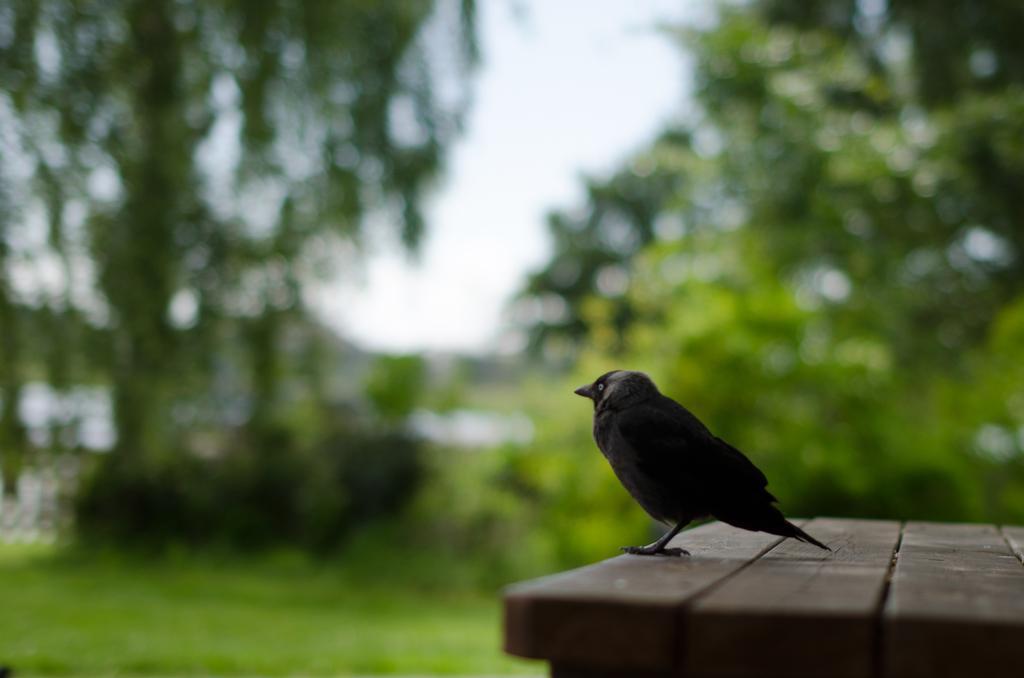Could you give a brief overview of what you see in this image? In this image there is a bird on the wooden surface. Background there are plants and trees on the grassland. Top of the image there is sky. 